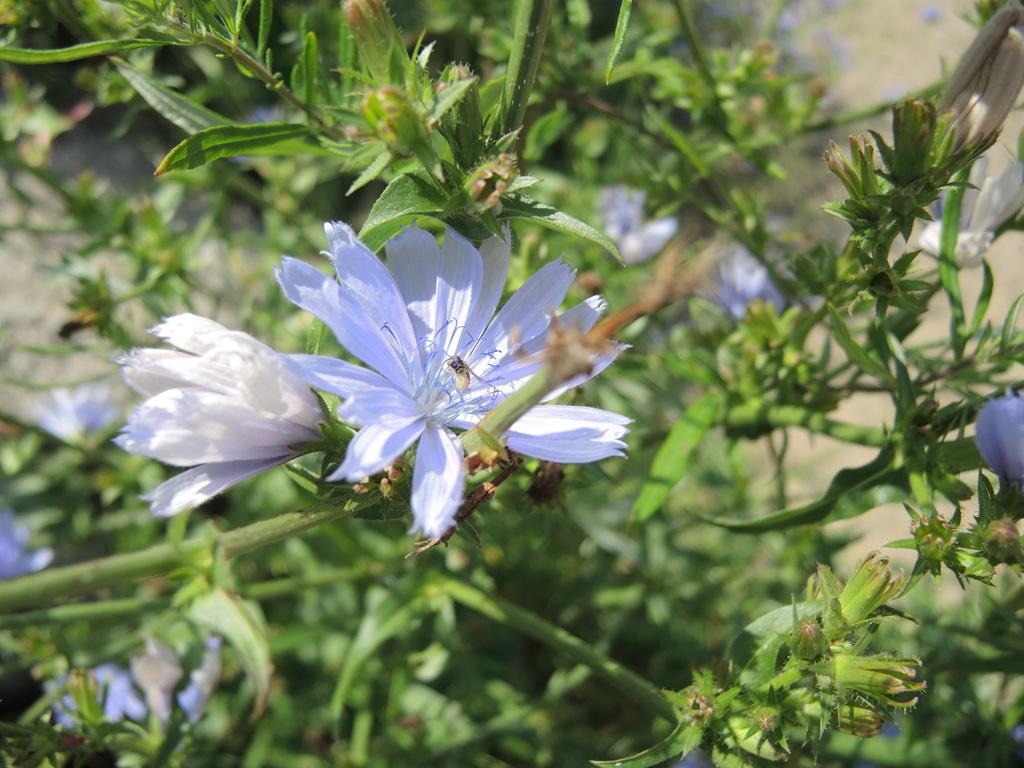What color are the flowers on the plant in the image? The flowers on the plant are white. Can you describe the background of the image? The background of the image is blurred. What grade does the skirt receive in the image? There is no skirt present in the image, so it is not possible to determine a grade. 